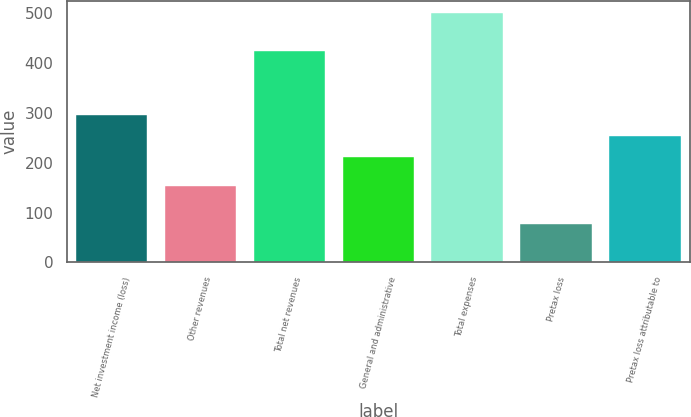Convert chart to OTSL. <chart><loc_0><loc_0><loc_500><loc_500><bar_chart><fcel>Net investment income (loss)<fcel>Other revenues<fcel>Total net revenues<fcel>General and administrative<fcel>Total expenses<fcel>Pretax loss<fcel>Pretax loss attributable to<nl><fcel>295.6<fcel>153<fcel>423<fcel>211<fcel>500<fcel>77<fcel>253.3<nl></chart> 